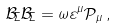<formula> <loc_0><loc_0><loc_500><loc_500>\mathcal { B } _ { \Sigma } \mathcal { B } _ { \Sigma } = \omega \varepsilon ^ { \mu } \mathcal { P } _ { \mu } \, ,</formula> 